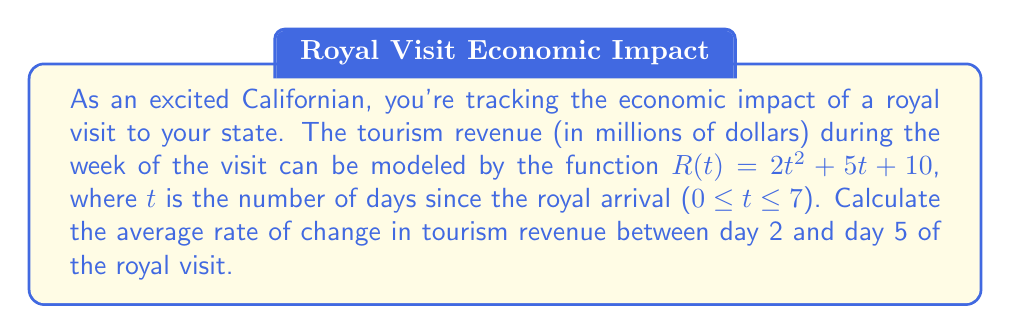Show me your answer to this math problem. To find the average rate of change between two points, we use the formula:

$$\text{Average rate of change} = \frac{\text{Change in y}}{\text{Change in x}} = \frac{f(b) - f(a)}{b - a}$$

Where $a$ and $b$ are the initial and final x-values, respectively.

In this case:
$a = 2$ (day 2)
$b = 5$ (day 5)

Let's calculate $R(2)$ and $R(5)$:

$R(2) = 2(2)^2 + 5(2) + 10 = 2(4) + 10 + 10 = 8 + 10 + 10 = 28$

$R(5) = 2(5)^2 + 5(5) + 10 = 2(25) + 25 + 10 = 50 + 25 + 10 = 85$

Now we can plug these values into our average rate of change formula:

$$\text{Average rate of change} = \frac{R(5) - R(2)}{5 - 2} = \frac{85 - 28}{3} = \frac{57}{3} = 19$$

Therefore, the average rate of change in tourism revenue between day 2 and day 5 is $19 million per day.
Answer: $19 million per day 